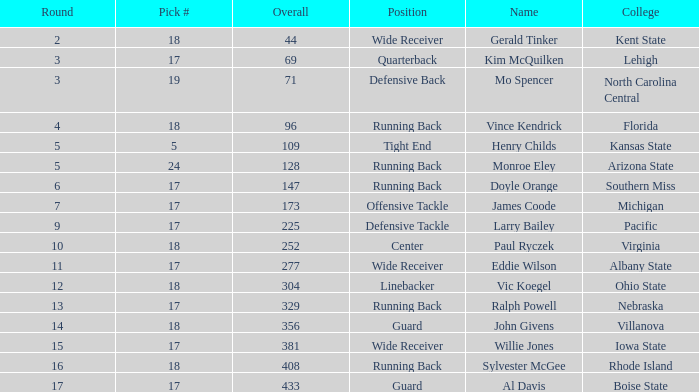Name the total number of round for wide receiver for kent state 1.0. Can you parse all the data within this table? {'header': ['Round', 'Pick #', 'Overall', 'Position', 'Name', 'College'], 'rows': [['2', '18', '44', 'Wide Receiver', 'Gerald Tinker', 'Kent State'], ['3', '17', '69', 'Quarterback', 'Kim McQuilken', 'Lehigh'], ['3', '19', '71', 'Defensive Back', 'Mo Spencer', 'North Carolina Central'], ['4', '18', '96', 'Running Back', 'Vince Kendrick', 'Florida'], ['5', '5', '109', 'Tight End', 'Henry Childs', 'Kansas State'], ['5', '24', '128', 'Running Back', 'Monroe Eley', 'Arizona State'], ['6', '17', '147', 'Running Back', 'Doyle Orange', 'Southern Miss'], ['7', '17', '173', 'Offensive Tackle', 'James Coode', 'Michigan'], ['9', '17', '225', 'Defensive Tackle', 'Larry Bailey', 'Pacific'], ['10', '18', '252', 'Center', 'Paul Ryczek', 'Virginia'], ['11', '17', '277', 'Wide Receiver', 'Eddie Wilson', 'Albany State'], ['12', '18', '304', 'Linebacker', 'Vic Koegel', 'Ohio State'], ['13', '17', '329', 'Running Back', 'Ralph Powell', 'Nebraska'], ['14', '18', '356', 'Guard', 'John Givens', 'Villanova'], ['15', '17', '381', 'Wide Receiver', 'Willie Jones', 'Iowa State'], ['16', '18', '408', 'Running Back', 'Sylvester McGee', 'Rhode Island'], ['17', '17', '433', 'Guard', 'Al Davis', 'Boise State']]} 